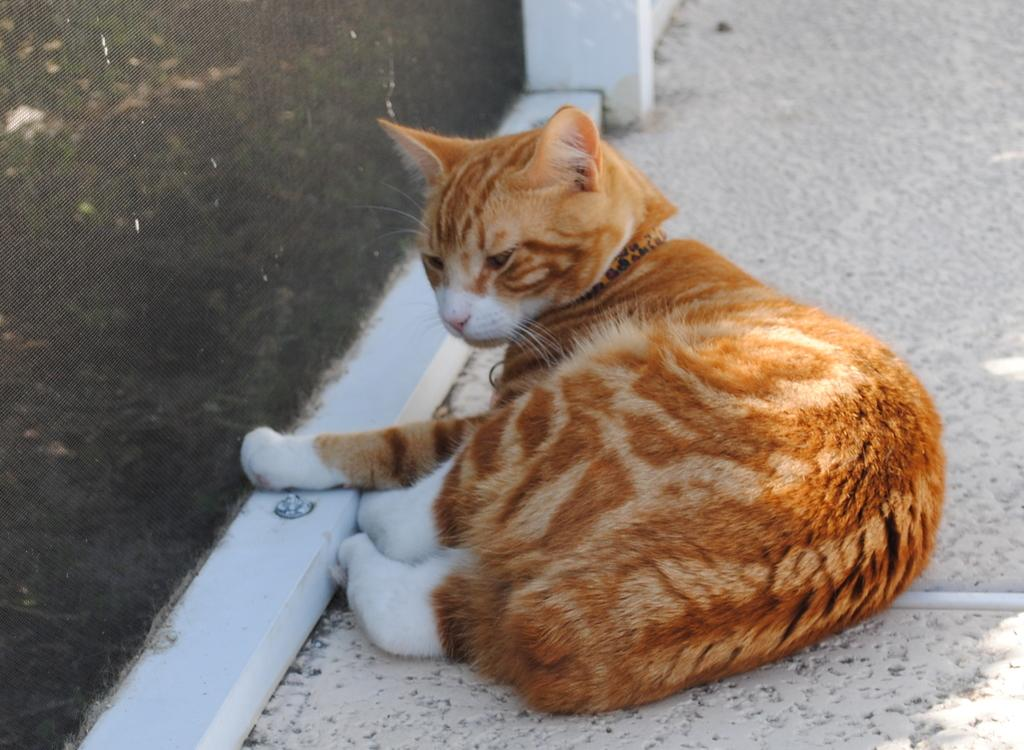What type of animal is in the image? There is a cat in the image. What is the cat sitting or standing on? The cat is on a surface in the image. What other object can be seen in the image? There is a fence in the image. What type of oil is being transported in the image? There is no oil or transportation depicted in the image; it features a cat on a surface and a fence. 